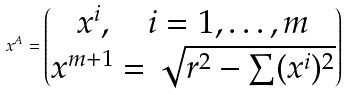<formula> <loc_0><loc_0><loc_500><loc_500>x ^ { A } = \begin{pmatrix} x ^ { i } , \quad i = 1 , \dots , m \\ x ^ { m + 1 } = \sqrt { r ^ { 2 } - \sum ( x ^ { i } ) ^ { 2 } } \end{pmatrix}</formula> 